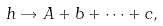Convert formula to latex. <formula><loc_0><loc_0><loc_500><loc_500>h \rightarrow A + b + \cdots + c ,</formula> 